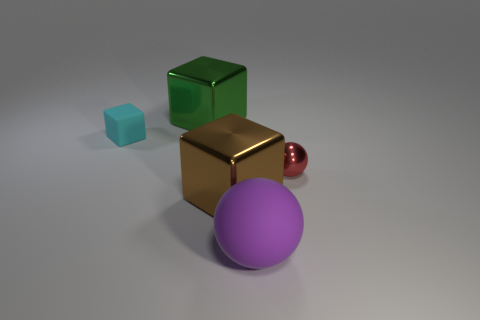Add 2 large brown objects. How many objects exist? 7 Subtract all metal cubes. How many cubes are left? 1 Subtract all cyan cubes. How many cubes are left? 2 Subtract 1 blocks. How many blocks are left? 2 Subtract all gray blocks. Subtract all cyan spheres. How many blocks are left? 3 Subtract all cyan cylinders. How many blue blocks are left? 0 Subtract all big gray matte cubes. Subtract all large metal things. How many objects are left? 3 Add 2 rubber objects. How many rubber objects are left? 4 Add 3 big objects. How many big objects exist? 6 Subtract 0 gray cylinders. How many objects are left? 5 